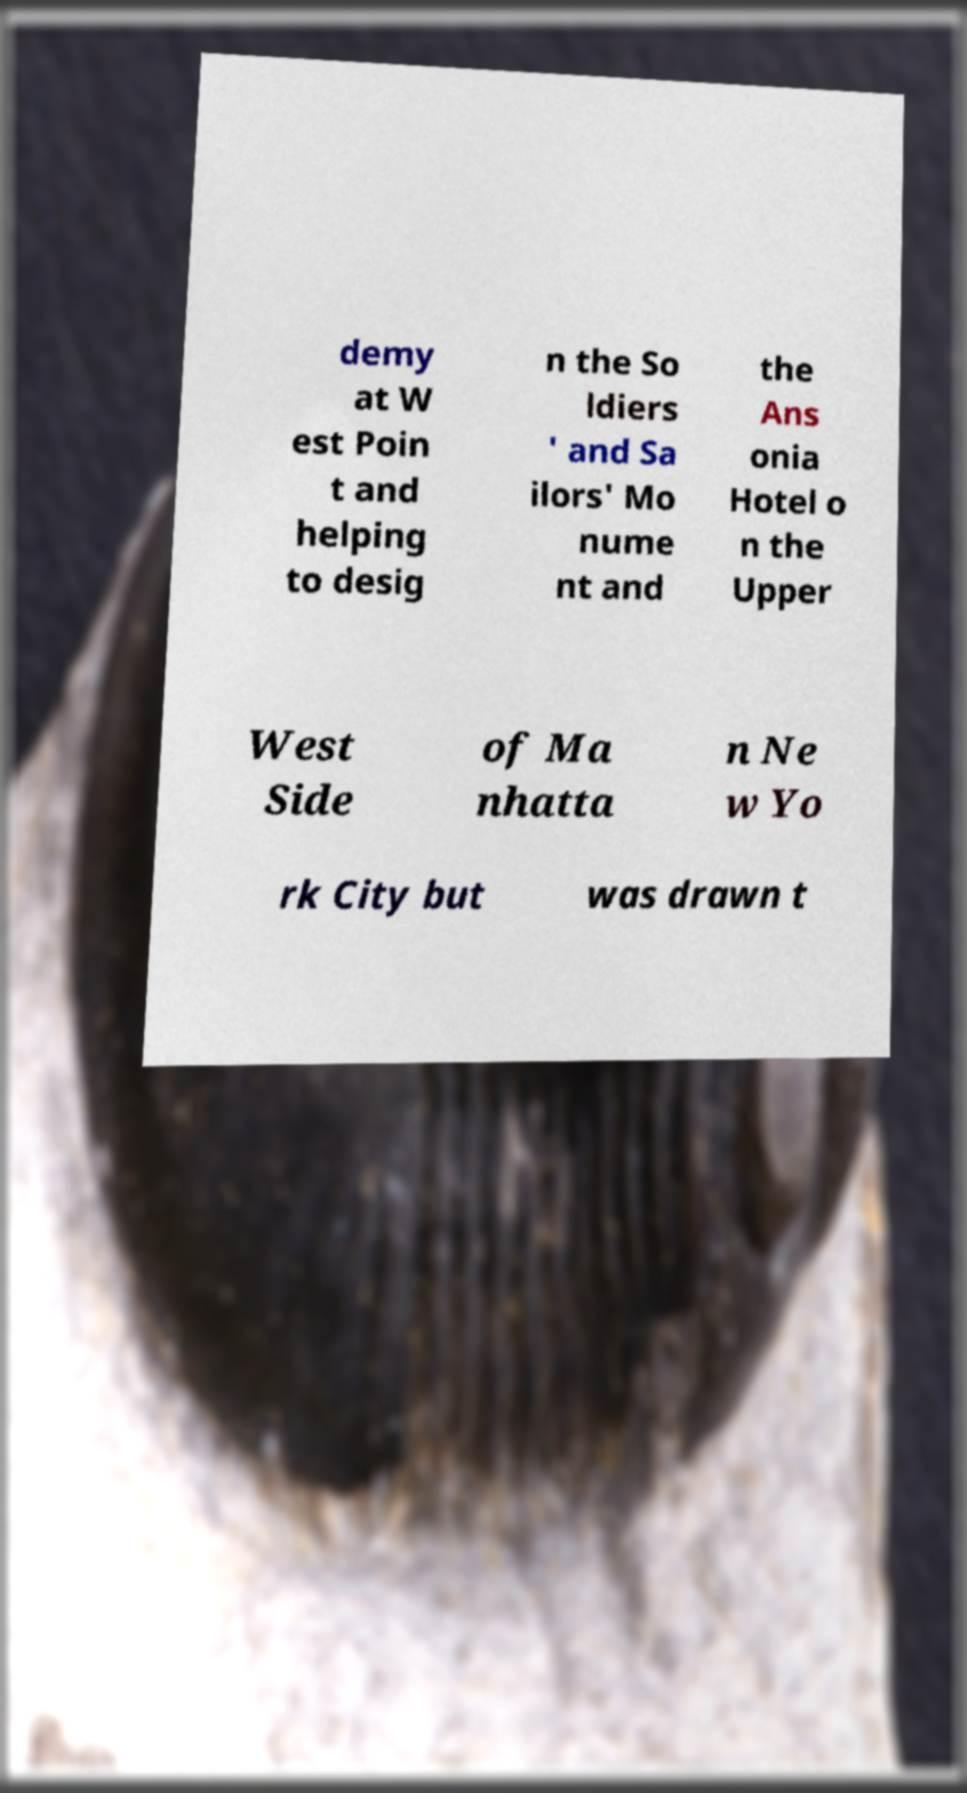Could you assist in decoding the text presented in this image and type it out clearly? demy at W est Poin t and helping to desig n the So ldiers ' and Sa ilors' Mo nume nt and the Ans onia Hotel o n the Upper West Side of Ma nhatta n Ne w Yo rk City but was drawn t 